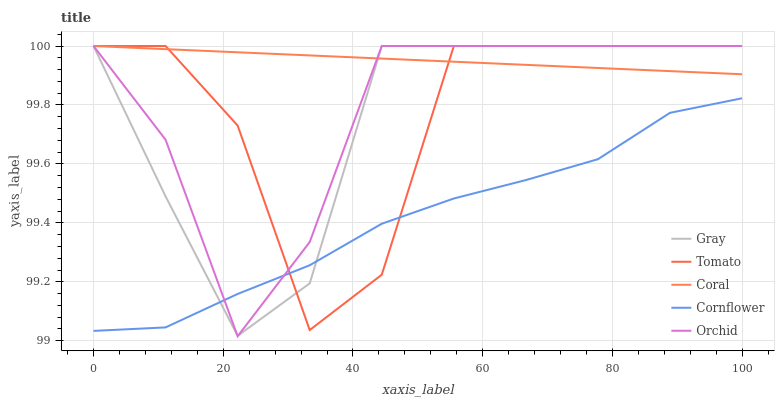Does Cornflower have the minimum area under the curve?
Answer yes or no. Yes. Does Coral have the maximum area under the curve?
Answer yes or no. Yes. Does Gray have the minimum area under the curve?
Answer yes or no. No. Does Gray have the maximum area under the curve?
Answer yes or no. No. Is Coral the smoothest?
Answer yes or no. Yes. Is Tomato the roughest?
Answer yes or no. Yes. Is Gray the smoothest?
Answer yes or no. No. Is Gray the roughest?
Answer yes or no. No. Does Orchid have the lowest value?
Answer yes or no. Yes. Does Gray have the lowest value?
Answer yes or no. No. Does Orchid have the highest value?
Answer yes or no. Yes. Does Cornflower have the highest value?
Answer yes or no. No. Is Cornflower less than Coral?
Answer yes or no. Yes. Is Coral greater than Cornflower?
Answer yes or no. Yes. Does Orchid intersect Cornflower?
Answer yes or no. Yes. Is Orchid less than Cornflower?
Answer yes or no. No. Is Orchid greater than Cornflower?
Answer yes or no. No. Does Cornflower intersect Coral?
Answer yes or no. No. 